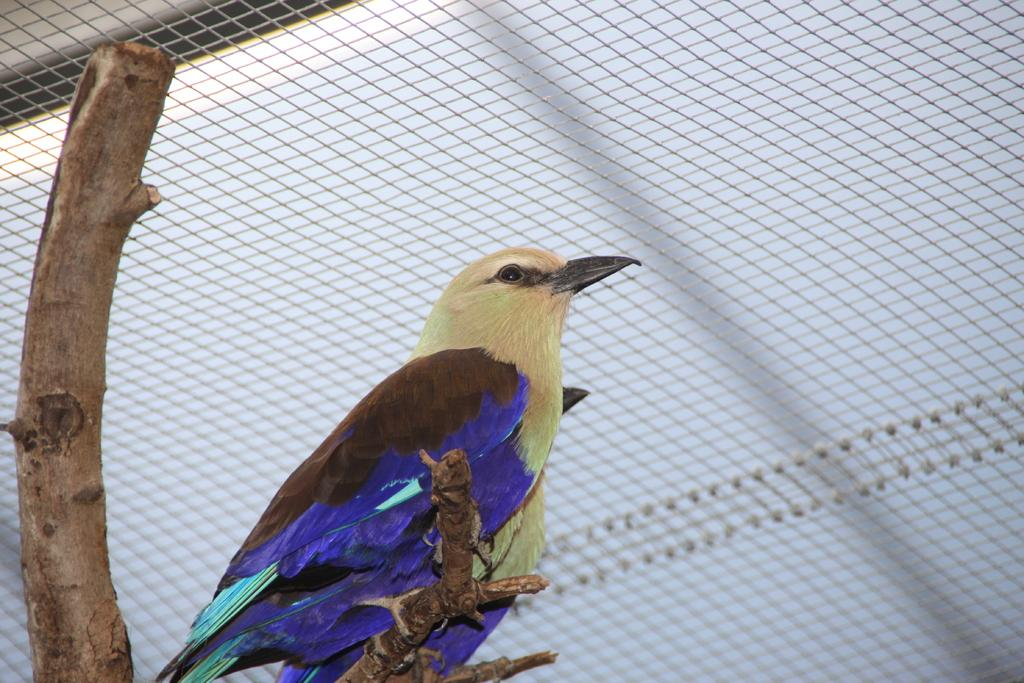What animals can be seen on the tree in the image? There are two birds visible on the trunk of a tree. What structure is located in the middle of the image? There is a fence in the middle of the image. What type of sheet is being used to protect the birds' throats in the image? There is no sheet or any indication of protecting the birds' throats in the image. What prose can be read on the fence in the image? There is no prose or text visible on the fence in the image. 